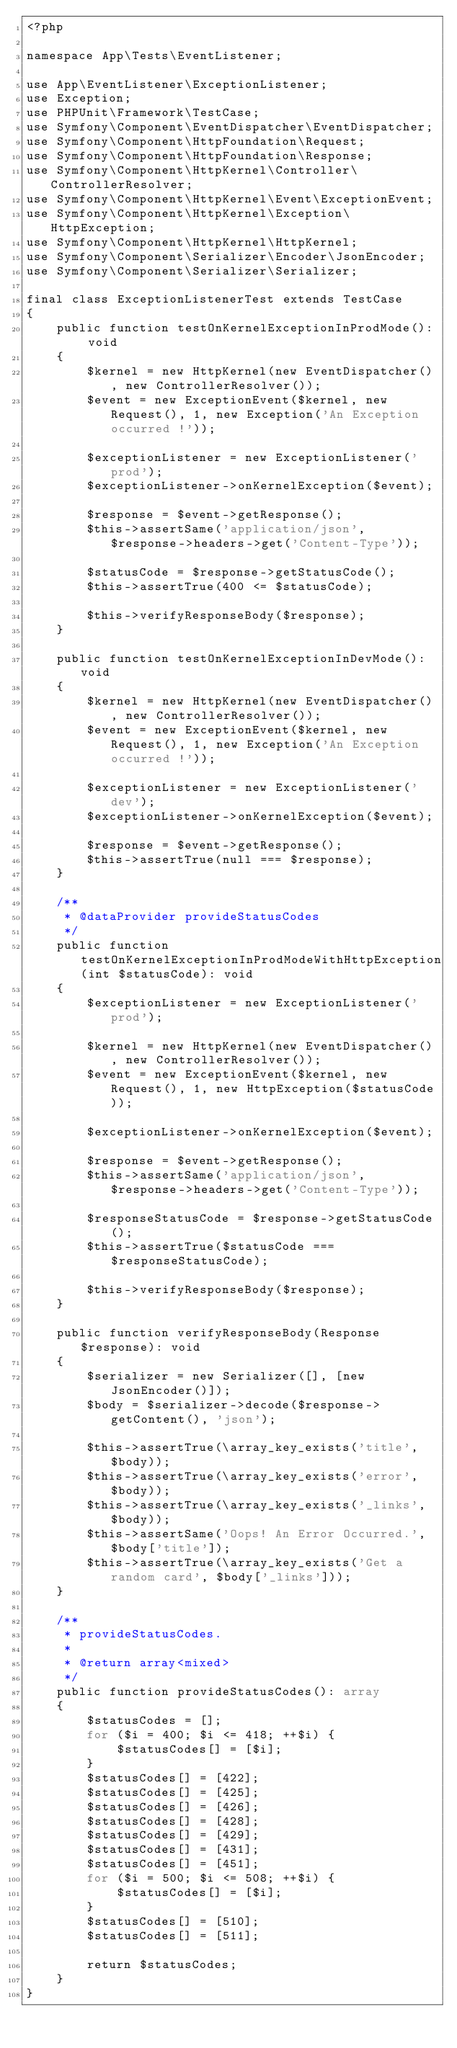Convert code to text. <code><loc_0><loc_0><loc_500><loc_500><_PHP_><?php

namespace App\Tests\EventListener;

use App\EventListener\ExceptionListener;
use Exception;
use PHPUnit\Framework\TestCase;
use Symfony\Component\EventDispatcher\EventDispatcher;
use Symfony\Component\HttpFoundation\Request;
use Symfony\Component\HttpFoundation\Response;
use Symfony\Component\HttpKernel\Controller\ControllerResolver;
use Symfony\Component\HttpKernel\Event\ExceptionEvent;
use Symfony\Component\HttpKernel\Exception\HttpException;
use Symfony\Component\HttpKernel\HttpKernel;
use Symfony\Component\Serializer\Encoder\JsonEncoder;
use Symfony\Component\Serializer\Serializer;

final class ExceptionListenerTest extends TestCase
{
    public function testOnKernelExceptionInProdMode(): void
    {
        $kernel = new HttpKernel(new EventDispatcher(), new ControllerResolver());
        $event = new ExceptionEvent($kernel, new Request(), 1, new Exception('An Exception occurred !'));

        $exceptionListener = new ExceptionListener('prod');
        $exceptionListener->onKernelException($event);

        $response = $event->getResponse();
        $this->assertSame('application/json', $response->headers->get('Content-Type'));

        $statusCode = $response->getStatusCode();
        $this->assertTrue(400 <= $statusCode);

        $this->verifyResponseBody($response);
    }

    public function testOnKernelExceptionInDevMode(): void
    {
        $kernel = new HttpKernel(new EventDispatcher(), new ControllerResolver());
        $event = new ExceptionEvent($kernel, new Request(), 1, new Exception('An Exception occurred !'));

        $exceptionListener = new ExceptionListener('dev');
        $exceptionListener->onKernelException($event);

        $response = $event->getResponse();
        $this->assertTrue(null === $response);
    }

    /**
     * @dataProvider provideStatusCodes
     */
    public function testOnKernelExceptionInProdModeWithHttpException(int $statusCode): void
    {
        $exceptionListener = new ExceptionListener('prod');

        $kernel = new HttpKernel(new EventDispatcher(), new ControllerResolver());
        $event = new ExceptionEvent($kernel, new Request(), 1, new HttpException($statusCode));

        $exceptionListener->onKernelException($event);

        $response = $event->getResponse();
        $this->assertSame('application/json', $response->headers->get('Content-Type'));

        $responseStatusCode = $response->getStatusCode();
        $this->assertTrue($statusCode === $responseStatusCode);

        $this->verifyResponseBody($response);
    }

    public function verifyResponseBody(Response $response): void
    {
        $serializer = new Serializer([], [new JsonEncoder()]);
        $body = $serializer->decode($response->getContent(), 'json');

        $this->assertTrue(\array_key_exists('title', $body));
        $this->assertTrue(\array_key_exists('error', $body));
        $this->assertTrue(\array_key_exists('_links', $body));
        $this->assertSame('Oops! An Error Occurred.', $body['title']);
        $this->assertTrue(\array_key_exists('Get a random card', $body['_links']));
    }

    /**
     * provideStatusCodes.
     *
     * @return array<mixed>
     */
    public function provideStatusCodes(): array
    {
        $statusCodes = [];
        for ($i = 400; $i <= 418; ++$i) {
            $statusCodes[] = [$i];
        }
        $statusCodes[] = [422];
        $statusCodes[] = [425];
        $statusCodes[] = [426];
        $statusCodes[] = [428];
        $statusCodes[] = [429];
        $statusCodes[] = [431];
        $statusCodes[] = [451];
        for ($i = 500; $i <= 508; ++$i) {
            $statusCodes[] = [$i];
        }
        $statusCodes[] = [510];
        $statusCodes[] = [511];

        return $statusCodes;
    }
}
</code> 